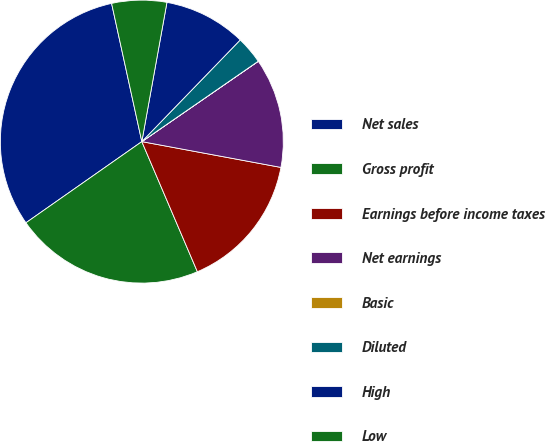<chart> <loc_0><loc_0><loc_500><loc_500><pie_chart><fcel>Net sales<fcel>Gross profit<fcel>Earnings before income taxes<fcel>Net earnings<fcel>Basic<fcel>Diluted<fcel>High<fcel>Low<nl><fcel>31.3%<fcel>21.7%<fcel>15.66%<fcel>12.53%<fcel>0.01%<fcel>3.14%<fcel>9.4%<fcel>6.27%<nl></chart> 